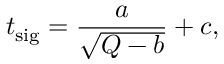<formula> <loc_0><loc_0><loc_500><loc_500>t _ { s i g } = \frac { a } { \sqrt { Q - b } } + c ,</formula> 